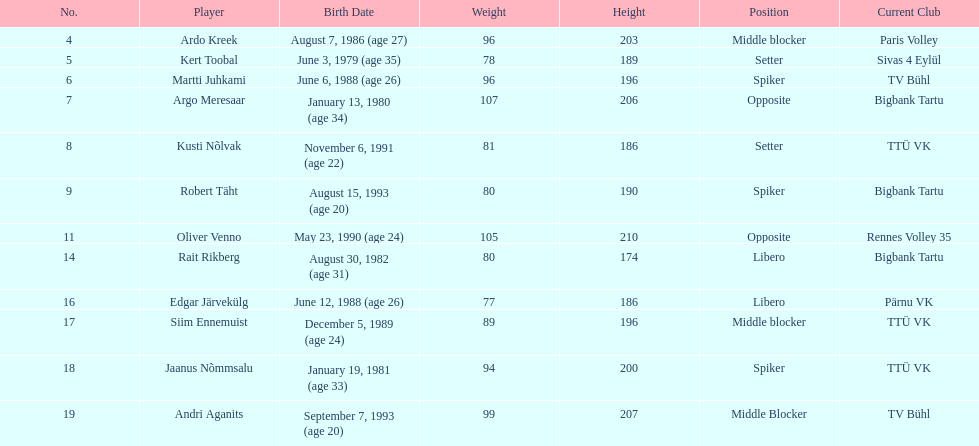Can you give me this table as a dict? {'header': ['No.', 'Player', 'Birth Date', 'Weight', 'Height', 'Position', 'Current Club'], 'rows': [['4', 'Ardo Kreek', 'August 7, 1986 (age\xa027)', '96', '203', 'Middle blocker', 'Paris Volley'], ['5', 'Kert Toobal', 'June 3, 1979 (age\xa035)', '78', '189', 'Setter', 'Sivas 4 Eylül'], ['6', 'Martti Juhkami', 'June 6, 1988 (age\xa026)', '96', '196', 'Spiker', 'TV Bühl'], ['7', 'Argo Meresaar', 'January 13, 1980 (age\xa034)', '107', '206', 'Opposite', 'Bigbank Tartu'], ['8', 'Kusti Nõlvak', 'November 6, 1991 (age\xa022)', '81', '186', 'Setter', 'TTÜ VK'], ['9', 'Robert Täht', 'August 15, 1993 (age\xa020)', '80', '190', 'Spiker', 'Bigbank Tartu'], ['11', 'Oliver Venno', 'May 23, 1990 (age\xa024)', '105', '210', 'Opposite', 'Rennes Volley 35'], ['14', 'Rait Rikberg', 'August 30, 1982 (age\xa031)', '80', '174', 'Libero', 'Bigbank Tartu'], ['16', 'Edgar Järvekülg', 'June 12, 1988 (age\xa026)', '77', '186', 'Libero', 'Pärnu VK'], ['17', 'Siim Ennemuist', 'December 5, 1989 (age\xa024)', '89', '196', 'Middle blocker', 'TTÜ VK'], ['18', 'Jaanus Nõmmsalu', 'January 19, 1981 (age\xa033)', '94', '200', 'Spiker', 'TTÜ VK'], ['19', 'Andri Aganits', 'September 7, 1993 (age\xa020)', '99', '207', 'Middle Blocker', 'TV Bühl']]} Which athletes held the same position as ardo kreek during their career? Siim Ennemuist, Andri Aganits. 